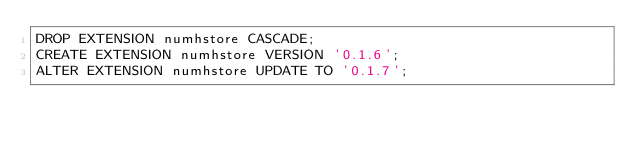<code> <loc_0><loc_0><loc_500><loc_500><_SQL_>DROP EXTENSION numhstore CASCADE;
CREATE EXTENSION numhstore VERSION '0.1.6';
ALTER EXTENSION numhstore UPDATE TO '0.1.7';</code> 